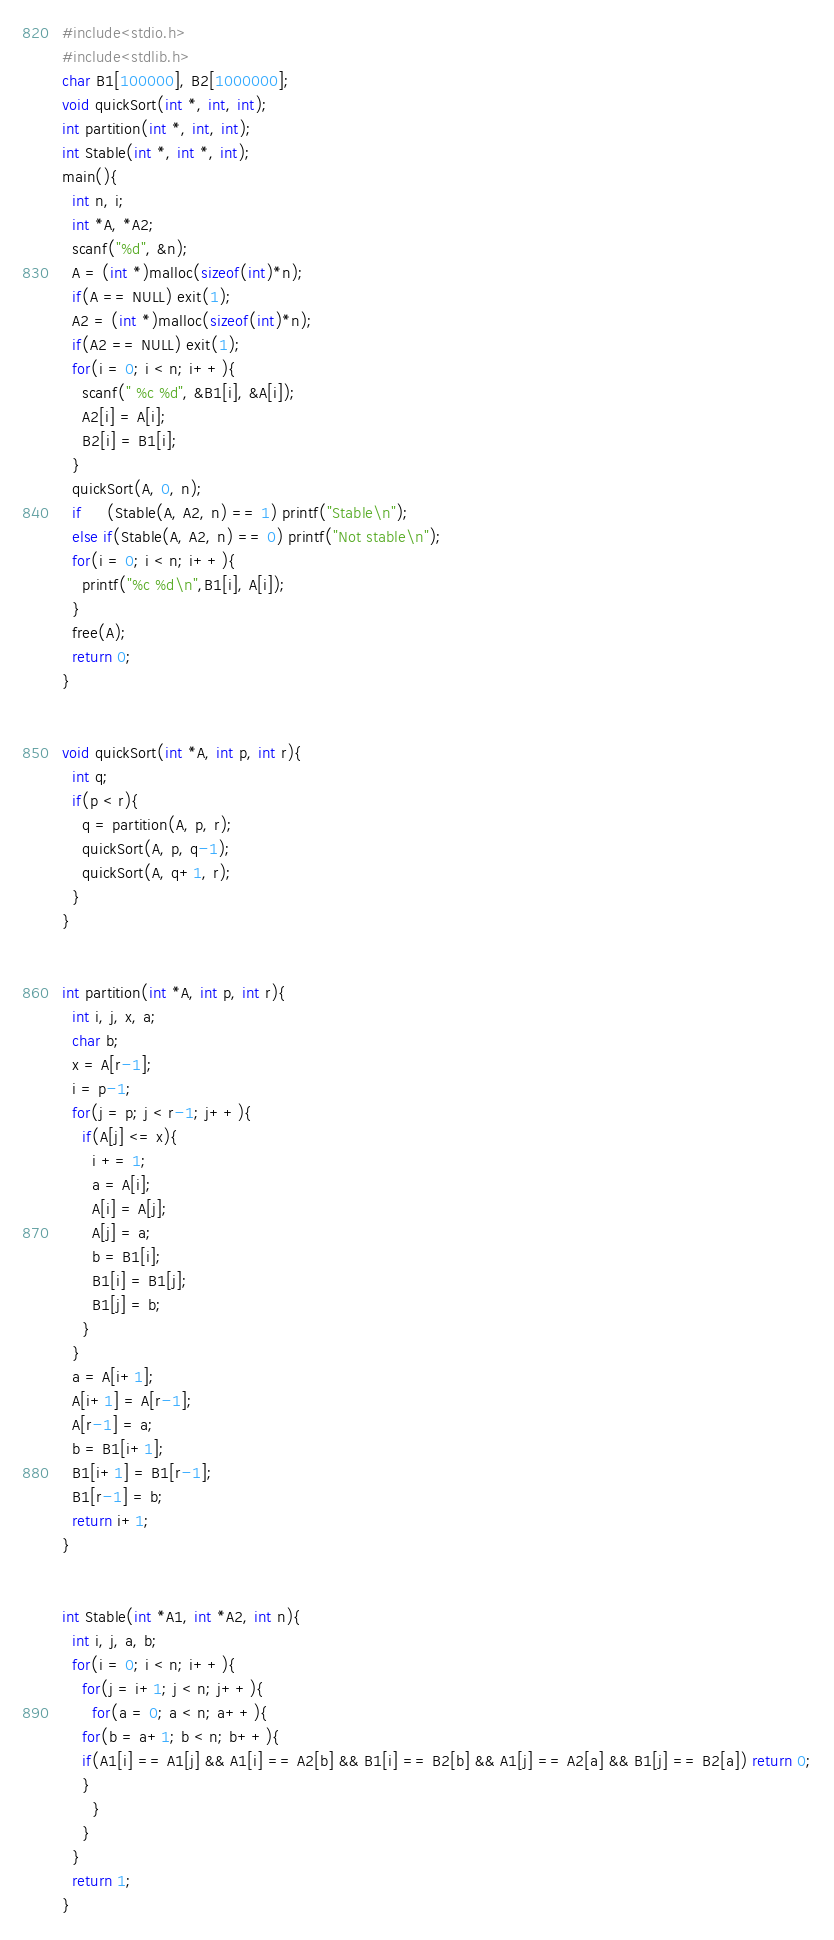<code> <loc_0><loc_0><loc_500><loc_500><_C_>#include<stdio.h>
#include<stdlib.h>
char B1[100000], B2[1000000];
void quickSort(int *, int, int);
int partition(int *, int, int);
int Stable(int *, int *, int);
main(){
  int n, i;
  int *A, *A2;
  scanf("%d", &n);
  A = (int *)malloc(sizeof(int)*n);
  if(A == NULL) exit(1);
  A2 = (int *)malloc(sizeof(int)*n);
  if(A2 == NULL) exit(1);
  for(i = 0; i < n; i++){
    scanf(" %c %d", &B1[i], &A[i]);
    A2[i] = A[i];
    B2[i] = B1[i];
  }
  quickSort(A, 0, n);
  if     (Stable(A, A2, n) == 1) printf("Stable\n");
  else if(Stable(A, A2, n) == 0) printf("Not stable\n");
  for(i = 0; i < n; i++){
    printf("%c %d\n",B1[i], A[i]);
  }
  free(A);
  return 0;
}


void quickSort(int *A, int p, int r){
  int q;
  if(p < r){
    q = partition(A, p, r);
    quickSort(A, p, q-1);
    quickSort(A, q+1, r);
  }
}


int partition(int *A, int p, int r){
  int i, j, x, a;
  char b;
  x = A[r-1];
  i = p-1;
  for(j = p; j < r-1; j++){
    if(A[j] <= x){
      i += 1;
      a = A[i];
      A[i] = A[j];
      A[j] = a;
      b = B1[i];
      B1[i] = B1[j];
      B1[j] = b;
    }
  }
  a = A[i+1];
  A[i+1] = A[r-1];
  A[r-1] = a;
  b = B1[i+1];
  B1[i+1] = B1[r-1];
  B1[r-1] = b;
  return i+1;
}


int Stable(int *A1, int *A2, int n){
  int i, j, a, b;
  for(i = 0; i < n; i++){
    for(j = i+1; j < n; j++){
      for(a = 0; a < n; a++){
	for(b = a+1; b < n; b++){
    if(A1[i] == A1[j] && A1[i] == A2[b] && B1[i] == B2[b] && A1[j] == A2[a] && B1[j] == B2[a]) return 0;
	}
      }
    }
  }
  return 1;
}</code> 